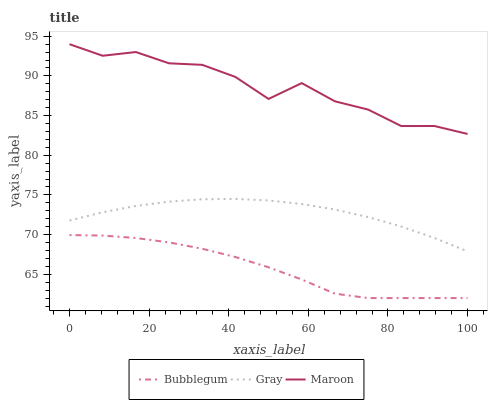Does Bubblegum have the minimum area under the curve?
Answer yes or no. Yes. Does Maroon have the maximum area under the curve?
Answer yes or no. Yes. Does Maroon have the minimum area under the curve?
Answer yes or no. No. Does Bubblegum have the maximum area under the curve?
Answer yes or no. No. Is Gray the smoothest?
Answer yes or no. Yes. Is Maroon the roughest?
Answer yes or no. Yes. Is Bubblegum the smoothest?
Answer yes or no. No. Is Bubblegum the roughest?
Answer yes or no. No. Does Bubblegum have the lowest value?
Answer yes or no. Yes. Does Maroon have the lowest value?
Answer yes or no. No. Does Maroon have the highest value?
Answer yes or no. Yes. Does Bubblegum have the highest value?
Answer yes or no. No. Is Bubblegum less than Maroon?
Answer yes or no. Yes. Is Maroon greater than Bubblegum?
Answer yes or no. Yes. Does Bubblegum intersect Maroon?
Answer yes or no. No. 